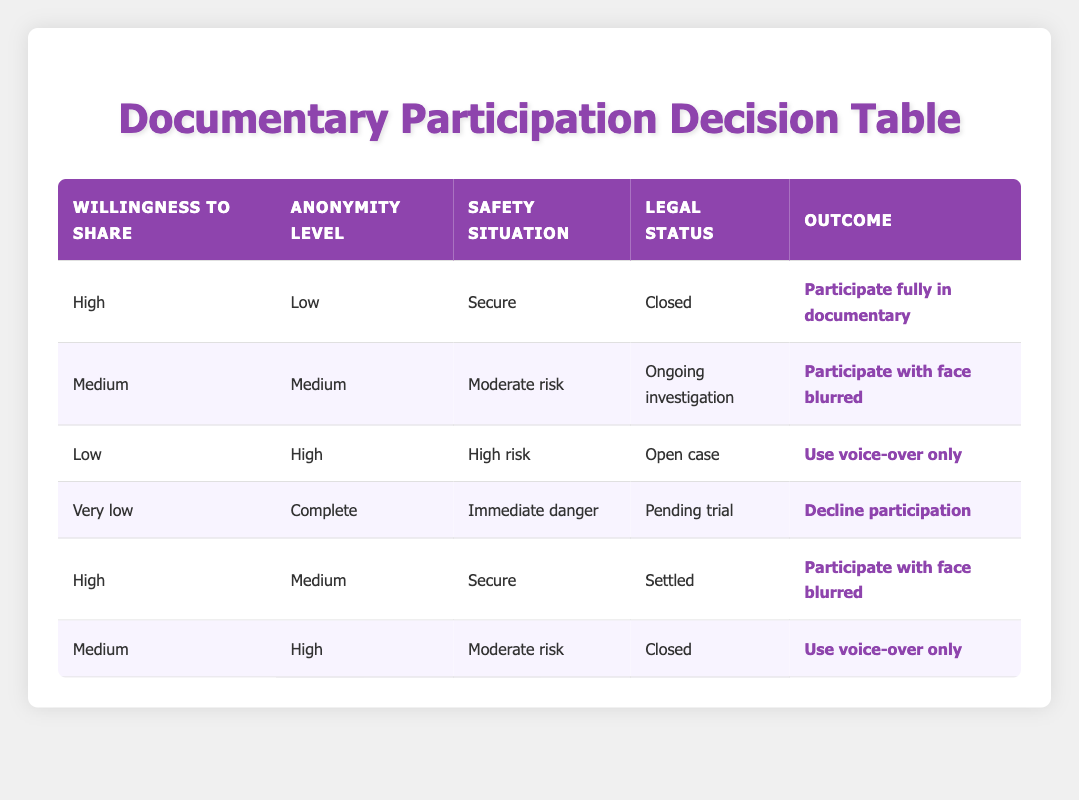What is the outcome if the willingness to share is high, anonymity is low, safety is secure, and the case is closed? According to the first row in the table, if the willingness to share is high, anonymity level is low, the safety situation is secure, and the legal status of the case is closed, the outcome is "Participate fully in documentary."
Answer: Participate fully in documentary If someone has a high level of anonymity requested and their situation is high risk, what is the likely outcome? Referring to the table, when the level of anonymity is high, the safety situation is high risk, and the willingness to share is low (as stated in the third row), the outcome would be "Use voice-over only."
Answer: Use voice-over only Are there any scenarios where a participant would decline participation? Yes, looking at the table, the last row indicates that if the willingness to share is very low, anonymity is complete, the safety situation is immediate danger, and the legal case is pending trial, the outcome would be to "Decline participation."
Answer: Yes What would be the outcome if the legal status of the case is ongoing investigation, and the safety situation is at moderate risk? In the table, the second row shows that if the legal status is an ongoing investigation, safety is moderate risk, and the willingness to share is medium with a medium anonymity level, the outcome is "Participate with face blurred."
Answer: Participate with face blurred What is the total number of outcomes listed for different conditions? To determine this, we count the number of unique outcomes in the table, which are: "Participate fully in documentary," "Participate with face blurred," "Use voice-over only," and "Decline participation." This gives us a total of four distinct outcomes.
Answer: Four If a participant wishes to maintain complete anonymity and feels immediate danger, is there any outcome other than declining participation? No, by examining the last row in the table, it is evident that the only outcome for a willingness to share that is very low, with a complete anonymity request in immediate danger, is to "Decline participation."
Answer: No What are the possible outcomes when participants have a high willingness to share but their legal case is ongoing investigation? The table's second row shows that if the willingness to share is high, anonymity is medium, the safety situation is moderate risk, and the legal status is ongoing investigation, the outcome is "Participate with face blurred."
Answer: Participate with face blurred What is the likelihood of using voice-over only if someone has medium anonymity and their legal case is closed? Referring to the fifth row, if the legal status is closed, with medium anonymity requested and a moderate safety situation combined with medium willingness to share, the outcome is "Use voice-over only." Therefore, in this specific scenario, it is likely to use voice-over only.
Answer: Likely to use voice-over only How many conditions involve a situation labeled as "Secure"? By reviewing the table, the conditions that indicate a "Secure" safety situation are present in the first and fifth rows. Therefore, there are two instances where the safety situation is secure.
Answer: Two 